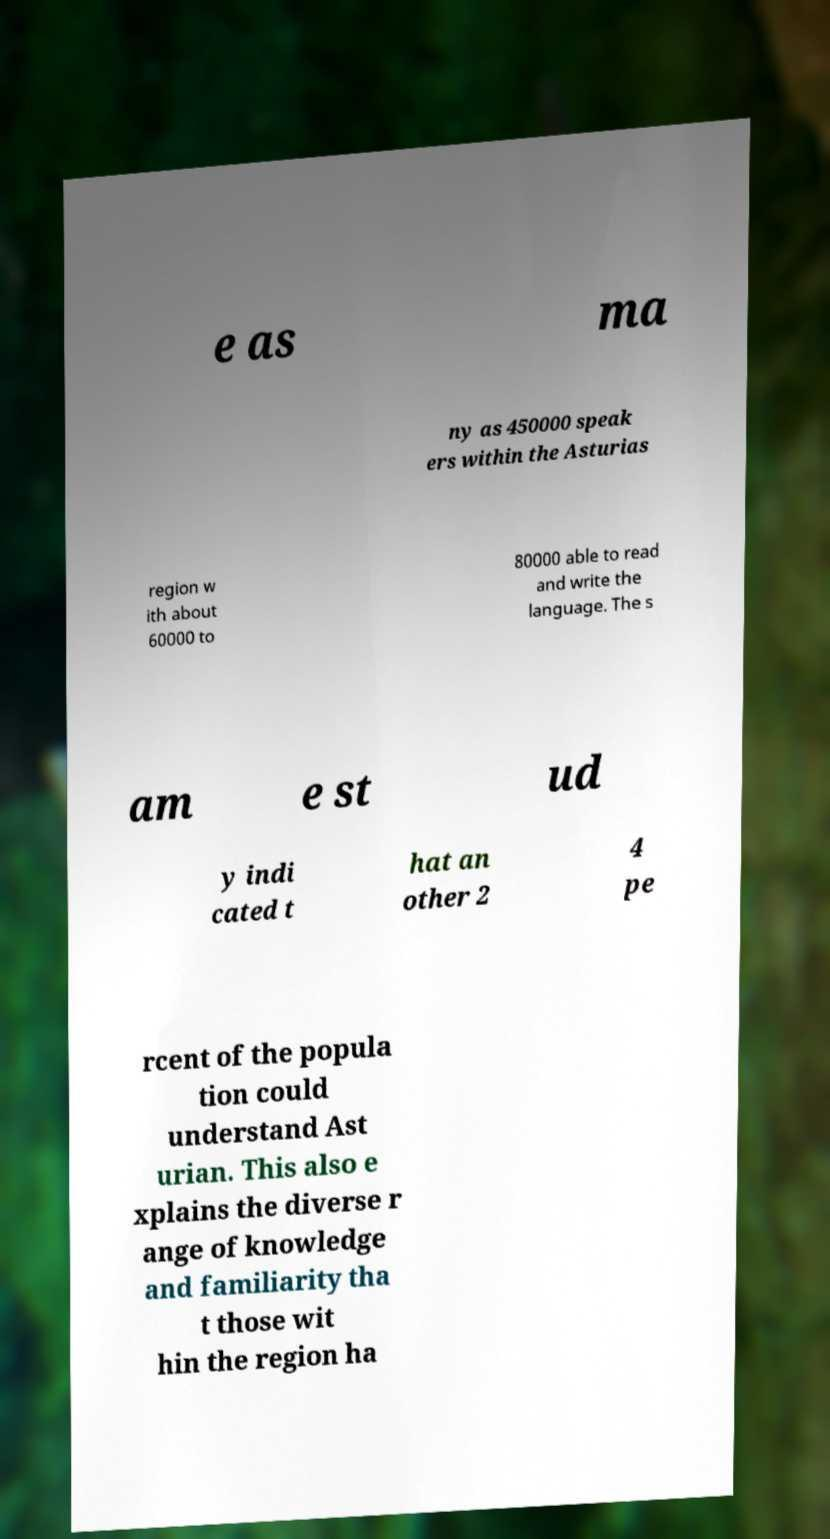There's text embedded in this image that I need extracted. Can you transcribe it verbatim? e as ma ny as 450000 speak ers within the Asturias region w ith about 60000 to 80000 able to read and write the language. The s am e st ud y indi cated t hat an other 2 4 pe rcent of the popula tion could understand Ast urian. This also e xplains the diverse r ange of knowledge and familiarity tha t those wit hin the region ha 